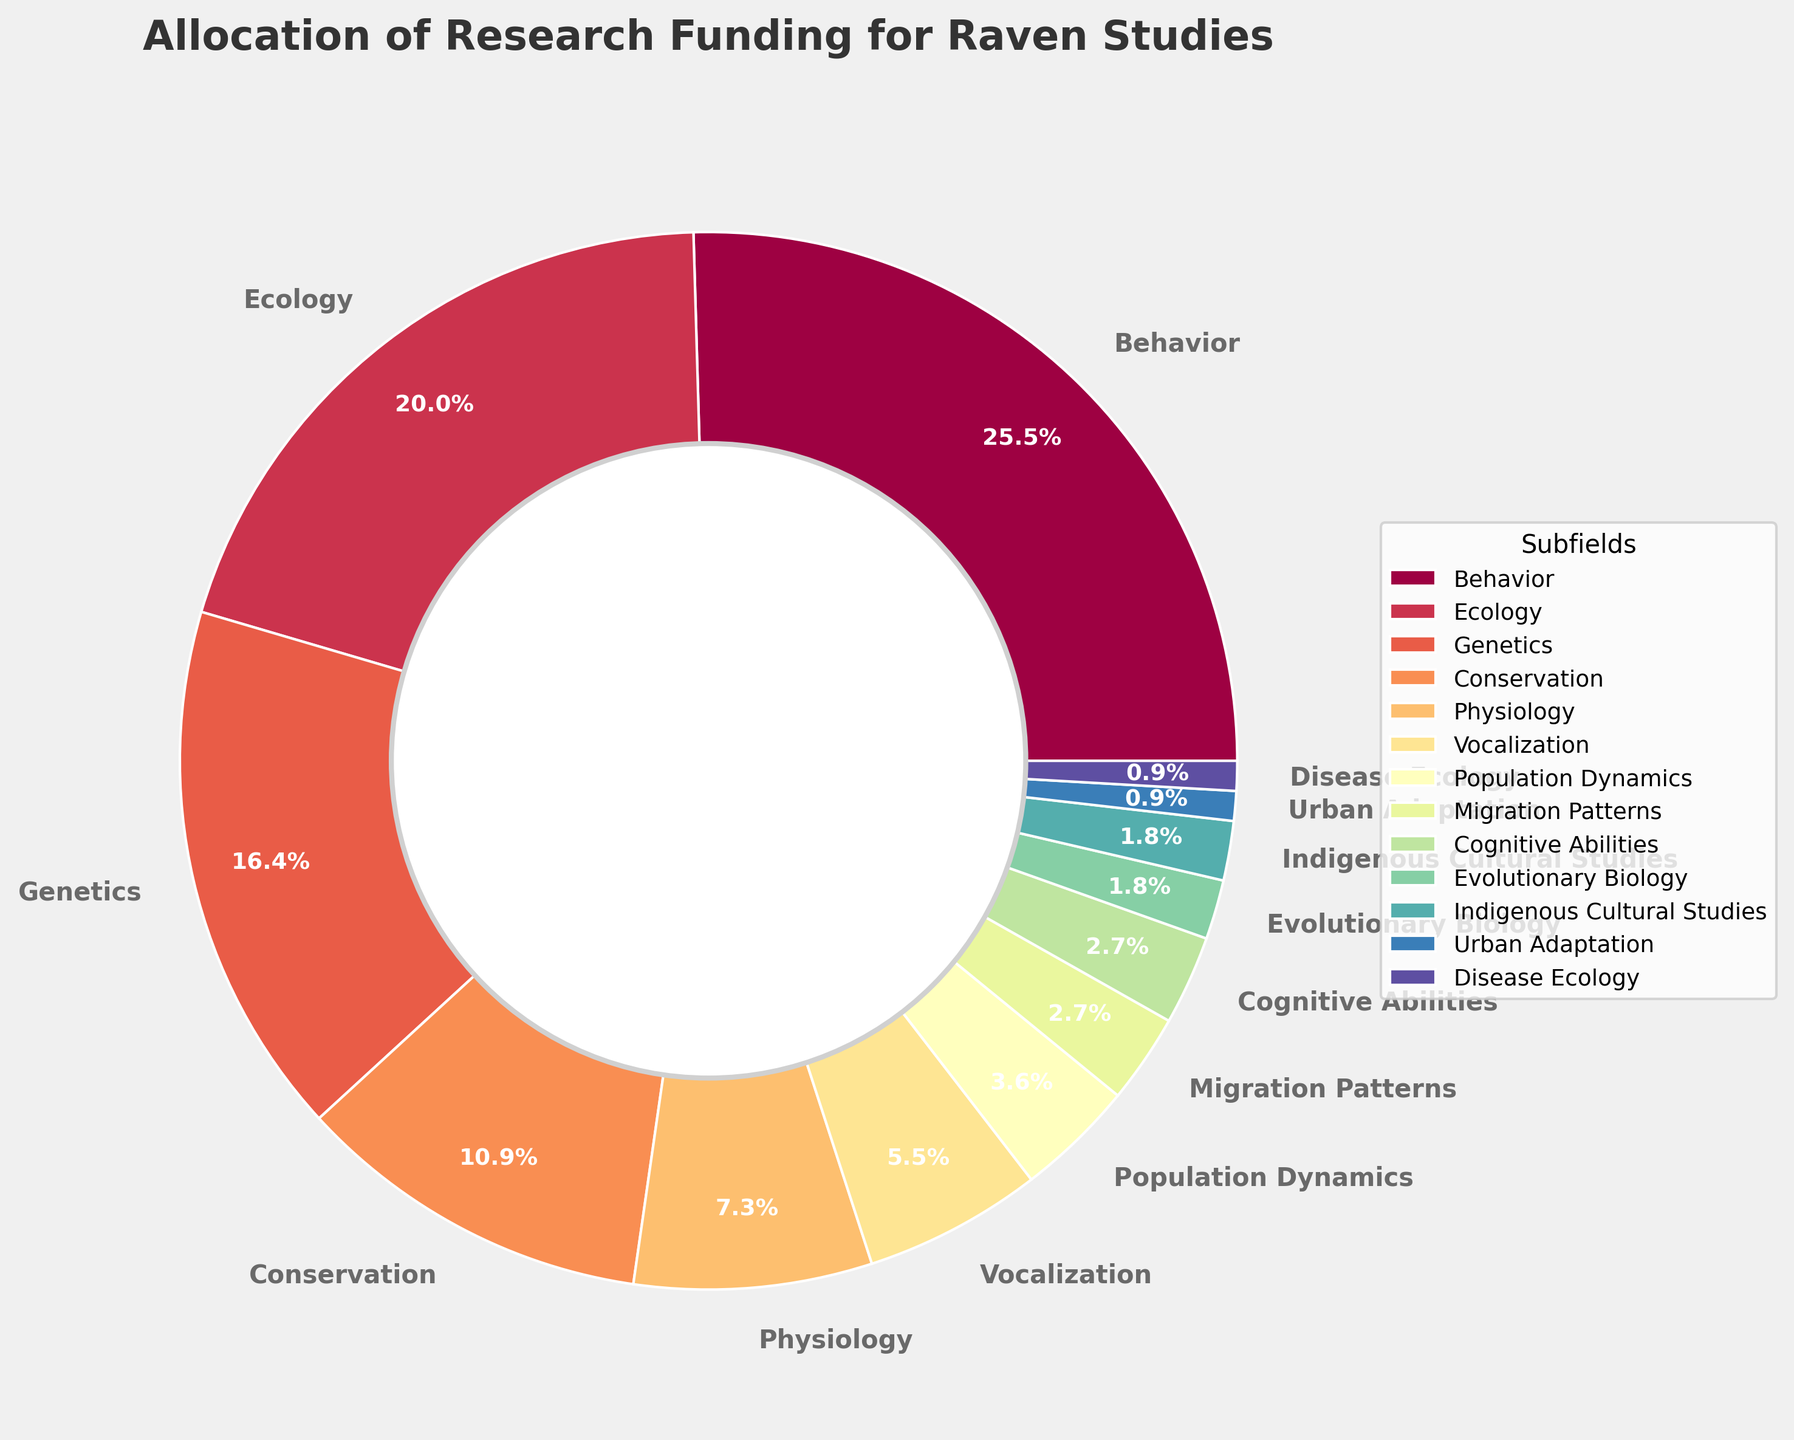Which subfield receives the highest percentage of research funding? The chart shows the allocation of funding with each section labeled by its percentage. The largest section represents the "Behavior" subfield, which is labeled as receiving 28%.
Answer: Behavior What is the combined funding percentage allocated to Genetics and Conservation subfields? Locate both "Genetics" and "Conservation" in the chart and sum their percentages: 18% + 12% = 30%.
Answer: 30% How much more funding does the Behavioral subfield receive compared to Ecology? The pie chart labels Behavior at 28% and Ecology at 22%. The difference is 28% - 22% = 6%.
Answer: 6% Which subfield gets more funding: Migration Patterns or Cognitive Abilities? The chart shows Migration Patterns at 3% and Cognitive Abilities also at 3%, so they receive equal funding.
Answer: They receive equal funding What is the percentage of funding for subfields related to physiology and vocalization combined? Find the percentages for both Physiology and Vocalization and add them together: 8% + 6% = 14%.
Answer: 14% How does the funding for Disease Ecology compare to Evolutionary Biology? The chart labels Disease Ecology and Evolutionary Biology both at 1% and 2%, respectively. Evolutionary Biology gets more by 1%.
Answer: Evolutionary Biology gets more by 1% What is the overall percentage of funding allocated to subfields less than 5%? Identify and sum subfields with <5%: Population Dynamics (4%), Migration Patterns (3%), Cognitive Abilities (3%), Evolutionary Biology (2%), Indigenous Cultural Studies (2%), Urban Adaptation (1%), and Disease Ecology (1%). Sum: 4% + 3% + 3% + 2% + 2% + 1% + 1% = 16%.
Answer: 16% Which subfield receives the smallest allocation of research funding? The chart shows Urban Adaptation and Disease Ecology with both at 1%, which are the smallest allocations.
Answer: Urban Adaptation and Disease Ecology How does the combined allocation of Ecology and Physiology compare to Behavior? The sizes of Ecology at 22% and Physiology at 8% combined sum to 30%, while Behavior alone is at 28%. Compare these totals: 30% > 28%.
Answer: Ecology and Physiology combined receive 2% more funding than Behavior What is the funding difference between the highest and lowest funded subfields? The highest funded, Behavior, gets 28%, while the lowest funded, Urban Adaptation and Disease Ecology, get 1% each. The difference is 28% - 1% = 27%.
Answer: 27% 